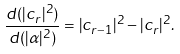<formula> <loc_0><loc_0><loc_500><loc_500>\frac { d ( | c _ { r } | ^ { 2 } ) } { d ( | { \alpha } | ^ { 2 } ) } = | c _ { r - 1 } | ^ { 2 } - | c _ { r } | ^ { 2 } .</formula> 